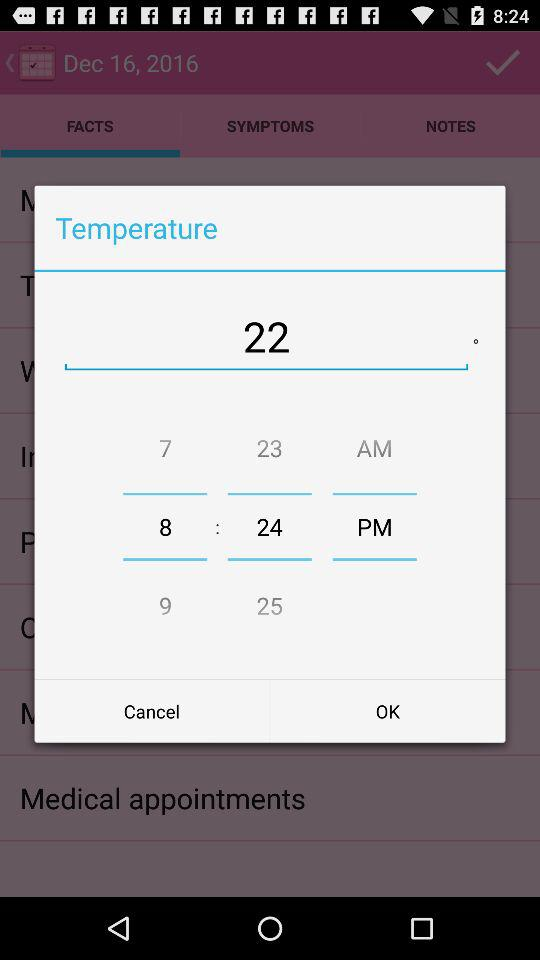What is the selected time? The selected time is 8:24 p.m. 